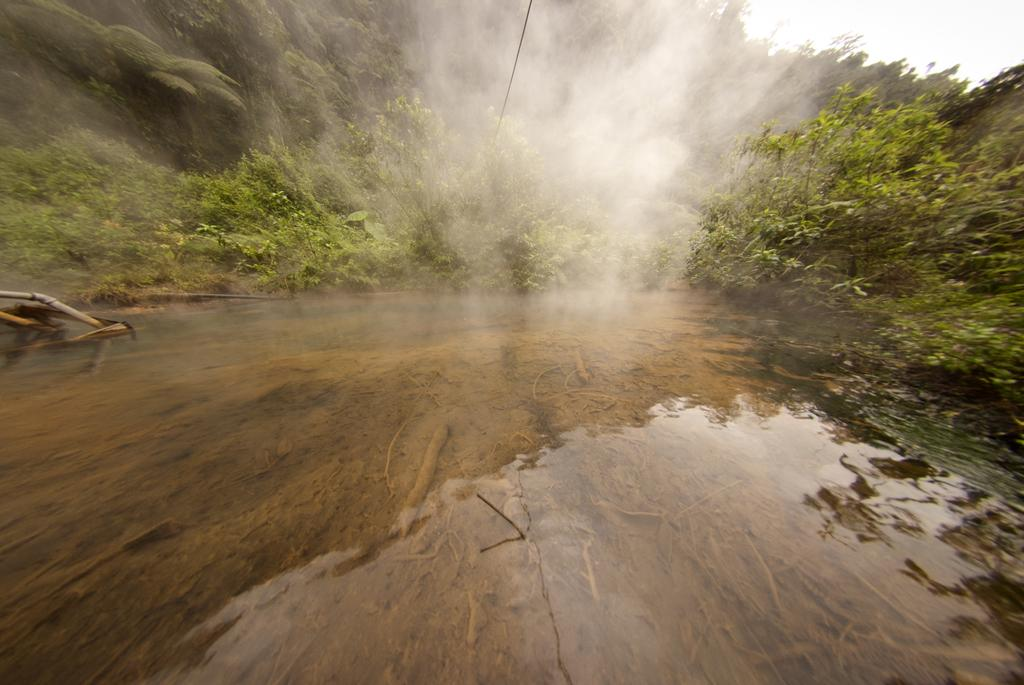What is present in the image that is related to water? There is water visible in the image. What type of object made of wood can be seen in the image? There is a wooden object in the image. What can be seen in the background of the image? There are trees, smoke, and the sky visible in the background of the image. What type of quilt is being used to cover the trees in the image? There is no quilt present in the image; it features trees, smoke, and the sky in the background. How many balls can be seen rolling down the wooden object in the image? There are no balls present in the image; it features a wooden object, water, and background elements. 